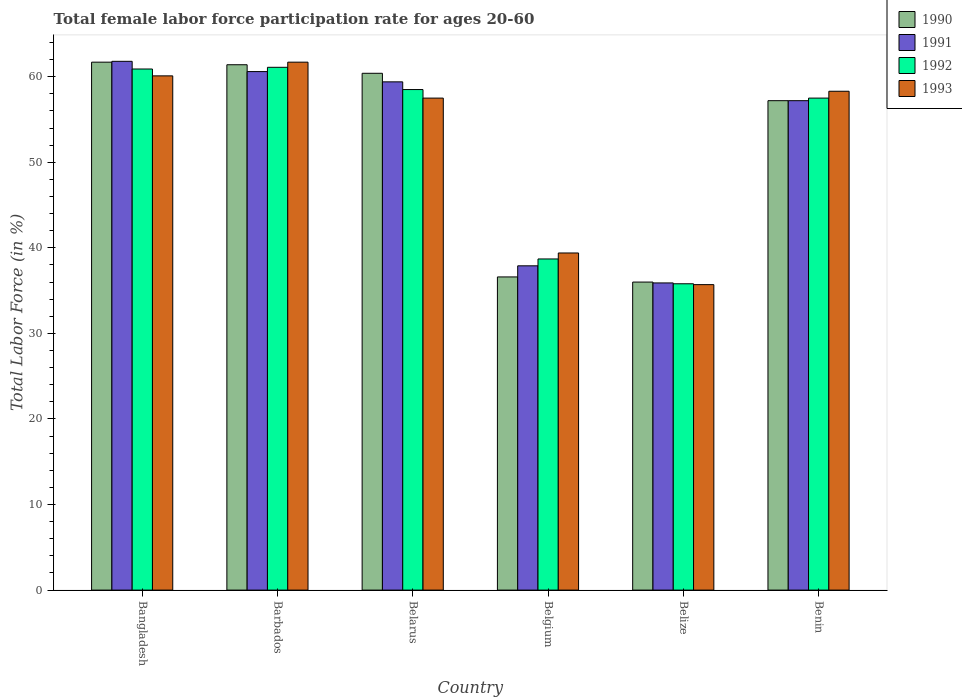How many different coloured bars are there?
Make the answer very short. 4. How many groups of bars are there?
Provide a short and direct response. 6. Are the number of bars per tick equal to the number of legend labels?
Your response must be concise. Yes. Are the number of bars on each tick of the X-axis equal?
Ensure brevity in your answer.  Yes. How many bars are there on the 3rd tick from the left?
Provide a succinct answer. 4. What is the label of the 5th group of bars from the left?
Provide a short and direct response. Belize. What is the female labor force participation rate in 1993 in Belarus?
Keep it short and to the point. 57.5. Across all countries, what is the maximum female labor force participation rate in 1993?
Make the answer very short. 61.7. Across all countries, what is the minimum female labor force participation rate in 1992?
Make the answer very short. 35.8. In which country was the female labor force participation rate in 1993 minimum?
Ensure brevity in your answer.  Belize. What is the total female labor force participation rate in 1992 in the graph?
Keep it short and to the point. 312.5. What is the difference between the female labor force participation rate in 1990 in Barbados and that in Benin?
Offer a very short reply. 4.2. What is the average female labor force participation rate in 1993 per country?
Your response must be concise. 52.12. What is the difference between the female labor force participation rate of/in 1990 and female labor force participation rate of/in 1993 in Belgium?
Make the answer very short. -2.8. In how many countries, is the female labor force participation rate in 1991 greater than 50 %?
Provide a short and direct response. 4. What is the ratio of the female labor force participation rate in 1992 in Bangladesh to that in Belgium?
Your answer should be compact. 1.57. Is the difference between the female labor force participation rate in 1990 in Belarus and Belgium greater than the difference between the female labor force participation rate in 1993 in Belarus and Belgium?
Ensure brevity in your answer.  Yes. What is the difference between the highest and the second highest female labor force participation rate in 1993?
Offer a terse response. -1.8. What is the difference between the highest and the lowest female labor force participation rate in 1990?
Provide a short and direct response. 25.7. In how many countries, is the female labor force participation rate in 1991 greater than the average female labor force participation rate in 1991 taken over all countries?
Offer a very short reply. 4. Is it the case that in every country, the sum of the female labor force participation rate in 1993 and female labor force participation rate in 1990 is greater than the sum of female labor force participation rate in 1991 and female labor force participation rate in 1992?
Your response must be concise. No. What does the 4th bar from the right in Belize represents?
Keep it short and to the point. 1990. Are all the bars in the graph horizontal?
Your response must be concise. No. Does the graph contain any zero values?
Offer a terse response. No. Where does the legend appear in the graph?
Provide a succinct answer. Top right. How many legend labels are there?
Offer a very short reply. 4. What is the title of the graph?
Make the answer very short. Total female labor force participation rate for ages 20-60. Does "2003" appear as one of the legend labels in the graph?
Give a very brief answer. No. What is the label or title of the X-axis?
Provide a short and direct response. Country. What is the label or title of the Y-axis?
Ensure brevity in your answer.  Total Labor Force (in %). What is the Total Labor Force (in %) in 1990 in Bangladesh?
Keep it short and to the point. 61.7. What is the Total Labor Force (in %) of 1991 in Bangladesh?
Keep it short and to the point. 61.8. What is the Total Labor Force (in %) of 1992 in Bangladesh?
Offer a terse response. 60.9. What is the Total Labor Force (in %) in 1993 in Bangladesh?
Your response must be concise. 60.1. What is the Total Labor Force (in %) in 1990 in Barbados?
Your answer should be very brief. 61.4. What is the Total Labor Force (in %) of 1991 in Barbados?
Offer a terse response. 60.6. What is the Total Labor Force (in %) in 1992 in Barbados?
Your answer should be very brief. 61.1. What is the Total Labor Force (in %) in 1993 in Barbados?
Provide a short and direct response. 61.7. What is the Total Labor Force (in %) in 1990 in Belarus?
Your response must be concise. 60.4. What is the Total Labor Force (in %) in 1991 in Belarus?
Your answer should be very brief. 59.4. What is the Total Labor Force (in %) of 1992 in Belarus?
Your answer should be compact. 58.5. What is the Total Labor Force (in %) of 1993 in Belarus?
Provide a succinct answer. 57.5. What is the Total Labor Force (in %) in 1990 in Belgium?
Give a very brief answer. 36.6. What is the Total Labor Force (in %) of 1991 in Belgium?
Make the answer very short. 37.9. What is the Total Labor Force (in %) of 1992 in Belgium?
Your answer should be compact. 38.7. What is the Total Labor Force (in %) in 1993 in Belgium?
Offer a terse response. 39.4. What is the Total Labor Force (in %) in 1991 in Belize?
Your answer should be very brief. 35.9. What is the Total Labor Force (in %) of 1992 in Belize?
Provide a short and direct response. 35.8. What is the Total Labor Force (in %) in 1993 in Belize?
Provide a succinct answer. 35.7. What is the Total Labor Force (in %) in 1990 in Benin?
Make the answer very short. 57.2. What is the Total Labor Force (in %) in 1991 in Benin?
Ensure brevity in your answer.  57.2. What is the Total Labor Force (in %) of 1992 in Benin?
Keep it short and to the point. 57.5. What is the Total Labor Force (in %) of 1993 in Benin?
Ensure brevity in your answer.  58.3. Across all countries, what is the maximum Total Labor Force (in %) of 1990?
Give a very brief answer. 61.7. Across all countries, what is the maximum Total Labor Force (in %) of 1991?
Provide a short and direct response. 61.8. Across all countries, what is the maximum Total Labor Force (in %) of 1992?
Your answer should be very brief. 61.1. Across all countries, what is the maximum Total Labor Force (in %) of 1993?
Ensure brevity in your answer.  61.7. Across all countries, what is the minimum Total Labor Force (in %) of 1990?
Make the answer very short. 36. Across all countries, what is the minimum Total Labor Force (in %) of 1991?
Your answer should be very brief. 35.9. Across all countries, what is the minimum Total Labor Force (in %) of 1992?
Make the answer very short. 35.8. Across all countries, what is the minimum Total Labor Force (in %) of 1993?
Your response must be concise. 35.7. What is the total Total Labor Force (in %) in 1990 in the graph?
Offer a very short reply. 313.3. What is the total Total Labor Force (in %) of 1991 in the graph?
Provide a short and direct response. 312.8. What is the total Total Labor Force (in %) in 1992 in the graph?
Give a very brief answer. 312.5. What is the total Total Labor Force (in %) of 1993 in the graph?
Keep it short and to the point. 312.7. What is the difference between the Total Labor Force (in %) in 1992 in Bangladesh and that in Barbados?
Make the answer very short. -0.2. What is the difference between the Total Labor Force (in %) in 1993 in Bangladesh and that in Barbados?
Provide a succinct answer. -1.6. What is the difference between the Total Labor Force (in %) in 1991 in Bangladesh and that in Belarus?
Make the answer very short. 2.4. What is the difference between the Total Labor Force (in %) of 1990 in Bangladesh and that in Belgium?
Offer a terse response. 25.1. What is the difference between the Total Labor Force (in %) of 1991 in Bangladesh and that in Belgium?
Offer a terse response. 23.9. What is the difference between the Total Labor Force (in %) of 1992 in Bangladesh and that in Belgium?
Offer a very short reply. 22.2. What is the difference between the Total Labor Force (in %) in 1993 in Bangladesh and that in Belgium?
Make the answer very short. 20.7. What is the difference between the Total Labor Force (in %) in 1990 in Bangladesh and that in Belize?
Your answer should be compact. 25.7. What is the difference between the Total Labor Force (in %) of 1991 in Bangladesh and that in Belize?
Your answer should be compact. 25.9. What is the difference between the Total Labor Force (in %) of 1992 in Bangladesh and that in Belize?
Your response must be concise. 25.1. What is the difference between the Total Labor Force (in %) of 1993 in Bangladesh and that in Belize?
Provide a succinct answer. 24.4. What is the difference between the Total Labor Force (in %) in 1990 in Bangladesh and that in Benin?
Your answer should be very brief. 4.5. What is the difference between the Total Labor Force (in %) in 1993 in Bangladesh and that in Benin?
Provide a short and direct response. 1.8. What is the difference between the Total Labor Force (in %) of 1991 in Barbados and that in Belarus?
Your response must be concise. 1.2. What is the difference between the Total Labor Force (in %) in 1992 in Barbados and that in Belarus?
Give a very brief answer. 2.6. What is the difference between the Total Labor Force (in %) in 1993 in Barbados and that in Belarus?
Ensure brevity in your answer.  4.2. What is the difference between the Total Labor Force (in %) in 1990 in Barbados and that in Belgium?
Give a very brief answer. 24.8. What is the difference between the Total Labor Force (in %) of 1991 in Barbados and that in Belgium?
Your answer should be very brief. 22.7. What is the difference between the Total Labor Force (in %) of 1992 in Barbados and that in Belgium?
Offer a terse response. 22.4. What is the difference between the Total Labor Force (in %) of 1993 in Barbados and that in Belgium?
Offer a terse response. 22.3. What is the difference between the Total Labor Force (in %) in 1990 in Barbados and that in Belize?
Your answer should be compact. 25.4. What is the difference between the Total Labor Force (in %) of 1991 in Barbados and that in Belize?
Make the answer very short. 24.7. What is the difference between the Total Labor Force (in %) in 1992 in Barbados and that in Belize?
Your answer should be very brief. 25.3. What is the difference between the Total Labor Force (in %) of 1990 in Barbados and that in Benin?
Your answer should be very brief. 4.2. What is the difference between the Total Labor Force (in %) in 1991 in Barbados and that in Benin?
Make the answer very short. 3.4. What is the difference between the Total Labor Force (in %) in 1993 in Barbados and that in Benin?
Make the answer very short. 3.4. What is the difference between the Total Labor Force (in %) in 1990 in Belarus and that in Belgium?
Offer a very short reply. 23.8. What is the difference between the Total Labor Force (in %) in 1992 in Belarus and that in Belgium?
Your answer should be compact. 19.8. What is the difference between the Total Labor Force (in %) in 1993 in Belarus and that in Belgium?
Ensure brevity in your answer.  18.1. What is the difference between the Total Labor Force (in %) in 1990 in Belarus and that in Belize?
Offer a very short reply. 24.4. What is the difference between the Total Labor Force (in %) in 1991 in Belarus and that in Belize?
Your answer should be compact. 23.5. What is the difference between the Total Labor Force (in %) in 1992 in Belarus and that in Belize?
Offer a very short reply. 22.7. What is the difference between the Total Labor Force (in %) of 1993 in Belarus and that in Belize?
Give a very brief answer. 21.8. What is the difference between the Total Labor Force (in %) in 1990 in Belarus and that in Benin?
Your answer should be very brief. 3.2. What is the difference between the Total Labor Force (in %) of 1991 in Belarus and that in Benin?
Offer a terse response. 2.2. What is the difference between the Total Labor Force (in %) of 1990 in Belgium and that in Belize?
Your response must be concise. 0.6. What is the difference between the Total Labor Force (in %) in 1992 in Belgium and that in Belize?
Your response must be concise. 2.9. What is the difference between the Total Labor Force (in %) in 1990 in Belgium and that in Benin?
Your response must be concise. -20.6. What is the difference between the Total Labor Force (in %) in 1991 in Belgium and that in Benin?
Keep it short and to the point. -19.3. What is the difference between the Total Labor Force (in %) of 1992 in Belgium and that in Benin?
Offer a terse response. -18.8. What is the difference between the Total Labor Force (in %) in 1993 in Belgium and that in Benin?
Make the answer very short. -18.9. What is the difference between the Total Labor Force (in %) in 1990 in Belize and that in Benin?
Provide a succinct answer. -21.2. What is the difference between the Total Labor Force (in %) of 1991 in Belize and that in Benin?
Your answer should be compact. -21.3. What is the difference between the Total Labor Force (in %) of 1992 in Belize and that in Benin?
Your response must be concise. -21.7. What is the difference between the Total Labor Force (in %) in 1993 in Belize and that in Benin?
Provide a succinct answer. -22.6. What is the difference between the Total Labor Force (in %) in 1990 in Bangladesh and the Total Labor Force (in %) in 1992 in Barbados?
Keep it short and to the point. 0.6. What is the difference between the Total Labor Force (in %) of 1990 in Bangladesh and the Total Labor Force (in %) of 1993 in Barbados?
Offer a very short reply. 0. What is the difference between the Total Labor Force (in %) in 1991 in Bangladesh and the Total Labor Force (in %) in 1992 in Barbados?
Make the answer very short. 0.7. What is the difference between the Total Labor Force (in %) of 1991 in Bangladesh and the Total Labor Force (in %) of 1993 in Barbados?
Give a very brief answer. 0.1. What is the difference between the Total Labor Force (in %) in 1992 in Bangladesh and the Total Labor Force (in %) in 1993 in Barbados?
Ensure brevity in your answer.  -0.8. What is the difference between the Total Labor Force (in %) of 1991 in Bangladesh and the Total Labor Force (in %) of 1993 in Belarus?
Keep it short and to the point. 4.3. What is the difference between the Total Labor Force (in %) in 1990 in Bangladesh and the Total Labor Force (in %) in 1991 in Belgium?
Your answer should be compact. 23.8. What is the difference between the Total Labor Force (in %) in 1990 in Bangladesh and the Total Labor Force (in %) in 1993 in Belgium?
Give a very brief answer. 22.3. What is the difference between the Total Labor Force (in %) of 1991 in Bangladesh and the Total Labor Force (in %) of 1992 in Belgium?
Ensure brevity in your answer.  23.1. What is the difference between the Total Labor Force (in %) in 1991 in Bangladesh and the Total Labor Force (in %) in 1993 in Belgium?
Your response must be concise. 22.4. What is the difference between the Total Labor Force (in %) of 1990 in Bangladesh and the Total Labor Force (in %) of 1991 in Belize?
Offer a very short reply. 25.8. What is the difference between the Total Labor Force (in %) of 1990 in Bangladesh and the Total Labor Force (in %) of 1992 in Belize?
Give a very brief answer. 25.9. What is the difference between the Total Labor Force (in %) in 1990 in Bangladesh and the Total Labor Force (in %) in 1993 in Belize?
Keep it short and to the point. 26. What is the difference between the Total Labor Force (in %) in 1991 in Bangladesh and the Total Labor Force (in %) in 1992 in Belize?
Your answer should be very brief. 26. What is the difference between the Total Labor Force (in %) of 1991 in Bangladesh and the Total Labor Force (in %) of 1993 in Belize?
Your answer should be compact. 26.1. What is the difference between the Total Labor Force (in %) in 1992 in Bangladesh and the Total Labor Force (in %) in 1993 in Belize?
Your answer should be compact. 25.2. What is the difference between the Total Labor Force (in %) in 1990 in Bangladesh and the Total Labor Force (in %) in 1991 in Benin?
Provide a succinct answer. 4.5. What is the difference between the Total Labor Force (in %) of 1990 in Bangladesh and the Total Labor Force (in %) of 1993 in Benin?
Your response must be concise. 3.4. What is the difference between the Total Labor Force (in %) of 1991 in Bangladesh and the Total Labor Force (in %) of 1992 in Benin?
Provide a short and direct response. 4.3. What is the difference between the Total Labor Force (in %) of 1991 in Bangladesh and the Total Labor Force (in %) of 1993 in Benin?
Provide a succinct answer. 3.5. What is the difference between the Total Labor Force (in %) in 1992 in Bangladesh and the Total Labor Force (in %) in 1993 in Benin?
Offer a terse response. 2.6. What is the difference between the Total Labor Force (in %) of 1990 in Barbados and the Total Labor Force (in %) of 1993 in Belarus?
Provide a short and direct response. 3.9. What is the difference between the Total Labor Force (in %) in 1991 in Barbados and the Total Labor Force (in %) in 1992 in Belarus?
Make the answer very short. 2.1. What is the difference between the Total Labor Force (in %) of 1991 in Barbados and the Total Labor Force (in %) of 1993 in Belarus?
Your response must be concise. 3.1. What is the difference between the Total Labor Force (in %) of 1990 in Barbados and the Total Labor Force (in %) of 1992 in Belgium?
Your response must be concise. 22.7. What is the difference between the Total Labor Force (in %) in 1991 in Barbados and the Total Labor Force (in %) in 1992 in Belgium?
Offer a very short reply. 21.9. What is the difference between the Total Labor Force (in %) of 1991 in Barbados and the Total Labor Force (in %) of 1993 in Belgium?
Make the answer very short. 21.2. What is the difference between the Total Labor Force (in %) of 1992 in Barbados and the Total Labor Force (in %) of 1993 in Belgium?
Provide a short and direct response. 21.7. What is the difference between the Total Labor Force (in %) of 1990 in Barbados and the Total Labor Force (in %) of 1992 in Belize?
Your answer should be very brief. 25.6. What is the difference between the Total Labor Force (in %) in 1990 in Barbados and the Total Labor Force (in %) in 1993 in Belize?
Give a very brief answer. 25.7. What is the difference between the Total Labor Force (in %) of 1991 in Barbados and the Total Labor Force (in %) of 1992 in Belize?
Ensure brevity in your answer.  24.8. What is the difference between the Total Labor Force (in %) in 1991 in Barbados and the Total Labor Force (in %) in 1993 in Belize?
Make the answer very short. 24.9. What is the difference between the Total Labor Force (in %) of 1992 in Barbados and the Total Labor Force (in %) of 1993 in Belize?
Your response must be concise. 25.4. What is the difference between the Total Labor Force (in %) of 1991 in Barbados and the Total Labor Force (in %) of 1993 in Benin?
Your response must be concise. 2.3. What is the difference between the Total Labor Force (in %) of 1990 in Belarus and the Total Labor Force (in %) of 1992 in Belgium?
Offer a terse response. 21.7. What is the difference between the Total Labor Force (in %) of 1991 in Belarus and the Total Labor Force (in %) of 1992 in Belgium?
Offer a very short reply. 20.7. What is the difference between the Total Labor Force (in %) in 1992 in Belarus and the Total Labor Force (in %) in 1993 in Belgium?
Make the answer very short. 19.1. What is the difference between the Total Labor Force (in %) in 1990 in Belarus and the Total Labor Force (in %) in 1992 in Belize?
Offer a very short reply. 24.6. What is the difference between the Total Labor Force (in %) of 1990 in Belarus and the Total Labor Force (in %) of 1993 in Belize?
Provide a short and direct response. 24.7. What is the difference between the Total Labor Force (in %) of 1991 in Belarus and the Total Labor Force (in %) of 1992 in Belize?
Provide a short and direct response. 23.6. What is the difference between the Total Labor Force (in %) of 1991 in Belarus and the Total Labor Force (in %) of 1993 in Belize?
Offer a very short reply. 23.7. What is the difference between the Total Labor Force (in %) of 1992 in Belarus and the Total Labor Force (in %) of 1993 in Belize?
Provide a succinct answer. 22.8. What is the difference between the Total Labor Force (in %) of 1990 in Belarus and the Total Labor Force (in %) of 1991 in Benin?
Your response must be concise. 3.2. What is the difference between the Total Labor Force (in %) in 1990 in Belarus and the Total Labor Force (in %) in 1992 in Benin?
Your answer should be very brief. 2.9. What is the difference between the Total Labor Force (in %) of 1992 in Belarus and the Total Labor Force (in %) of 1993 in Benin?
Your answer should be very brief. 0.2. What is the difference between the Total Labor Force (in %) in 1990 in Belgium and the Total Labor Force (in %) in 1991 in Belize?
Keep it short and to the point. 0.7. What is the difference between the Total Labor Force (in %) in 1990 in Belgium and the Total Labor Force (in %) in 1993 in Belize?
Give a very brief answer. 0.9. What is the difference between the Total Labor Force (in %) in 1990 in Belgium and the Total Labor Force (in %) in 1991 in Benin?
Your answer should be compact. -20.6. What is the difference between the Total Labor Force (in %) of 1990 in Belgium and the Total Labor Force (in %) of 1992 in Benin?
Make the answer very short. -20.9. What is the difference between the Total Labor Force (in %) in 1990 in Belgium and the Total Labor Force (in %) in 1993 in Benin?
Your answer should be very brief. -21.7. What is the difference between the Total Labor Force (in %) in 1991 in Belgium and the Total Labor Force (in %) in 1992 in Benin?
Your response must be concise. -19.6. What is the difference between the Total Labor Force (in %) of 1991 in Belgium and the Total Labor Force (in %) of 1993 in Benin?
Make the answer very short. -20.4. What is the difference between the Total Labor Force (in %) in 1992 in Belgium and the Total Labor Force (in %) in 1993 in Benin?
Provide a short and direct response. -19.6. What is the difference between the Total Labor Force (in %) of 1990 in Belize and the Total Labor Force (in %) of 1991 in Benin?
Make the answer very short. -21.2. What is the difference between the Total Labor Force (in %) in 1990 in Belize and the Total Labor Force (in %) in 1992 in Benin?
Make the answer very short. -21.5. What is the difference between the Total Labor Force (in %) in 1990 in Belize and the Total Labor Force (in %) in 1993 in Benin?
Give a very brief answer. -22.3. What is the difference between the Total Labor Force (in %) of 1991 in Belize and the Total Labor Force (in %) of 1992 in Benin?
Provide a succinct answer. -21.6. What is the difference between the Total Labor Force (in %) in 1991 in Belize and the Total Labor Force (in %) in 1993 in Benin?
Provide a succinct answer. -22.4. What is the difference between the Total Labor Force (in %) in 1992 in Belize and the Total Labor Force (in %) in 1993 in Benin?
Provide a succinct answer. -22.5. What is the average Total Labor Force (in %) in 1990 per country?
Offer a very short reply. 52.22. What is the average Total Labor Force (in %) in 1991 per country?
Ensure brevity in your answer.  52.13. What is the average Total Labor Force (in %) of 1992 per country?
Give a very brief answer. 52.08. What is the average Total Labor Force (in %) of 1993 per country?
Provide a succinct answer. 52.12. What is the difference between the Total Labor Force (in %) of 1990 and Total Labor Force (in %) of 1993 in Bangladesh?
Your answer should be very brief. 1.6. What is the difference between the Total Labor Force (in %) in 1992 and Total Labor Force (in %) in 1993 in Bangladesh?
Ensure brevity in your answer.  0.8. What is the difference between the Total Labor Force (in %) of 1990 and Total Labor Force (in %) of 1992 in Barbados?
Give a very brief answer. 0.3. What is the difference between the Total Labor Force (in %) of 1991 and Total Labor Force (in %) of 1992 in Barbados?
Keep it short and to the point. -0.5. What is the difference between the Total Labor Force (in %) of 1991 and Total Labor Force (in %) of 1993 in Barbados?
Provide a short and direct response. -1.1. What is the difference between the Total Labor Force (in %) of 1992 and Total Labor Force (in %) of 1993 in Barbados?
Provide a succinct answer. -0.6. What is the difference between the Total Labor Force (in %) of 1990 and Total Labor Force (in %) of 1991 in Belarus?
Offer a very short reply. 1. What is the difference between the Total Labor Force (in %) in 1990 and Total Labor Force (in %) in 1992 in Belarus?
Give a very brief answer. 1.9. What is the difference between the Total Labor Force (in %) of 1991 and Total Labor Force (in %) of 1992 in Belarus?
Your response must be concise. 0.9. What is the difference between the Total Labor Force (in %) in 1992 and Total Labor Force (in %) in 1993 in Belarus?
Provide a succinct answer. 1. What is the difference between the Total Labor Force (in %) of 1990 and Total Labor Force (in %) of 1992 in Belgium?
Offer a very short reply. -2.1. What is the difference between the Total Labor Force (in %) of 1991 and Total Labor Force (in %) of 1992 in Belgium?
Make the answer very short. -0.8. What is the difference between the Total Labor Force (in %) of 1991 and Total Labor Force (in %) of 1993 in Belgium?
Keep it short and to the point. -1.5. What is the difference between the Total Labor Force (in %) of 1990 and Total Labor Force (in %) of 1992 in Belize?
Your response must be concise. 0.2. What is the difference between the Total Labor Force (in %) in 1991 and Total Labor Force (in %) in 1992 in Belize?
Provide a succinct answer. 0.1. What is the difference between the Total Labor Force (in %) in 1990 and Total Labor Force (in %) in 1991 in Benin?
Your answer should be very brief. 0. What is the difference between the Total Labor Force (in %) of 1990 and Total Labor Force (in %) of 1992 in Benin?
Offer a terse response. -0.3. What is the difference between the Total Labor Force (in %) in 1991 and Total Labor Force (in %) in 1993 in Benin?
Keep it short and to the point. -1.1. What is the ratio of the Total Labor Force (in %) of 1990 in Bangladesh to that in Barbados?
Make the answer very short. 1. What is the ratio of the Total Labor Force (in %) in 1991 in Bangladesh to that in Barbados?
Give a very brief answer. 1.02. What is the ratio of the Total Labor Force (in %) of 1992 in Bangladesh to that in Barbados?
Give a very brief answer. 1. What is the ratio of the Total Labor Force (in %) in 1993 in Bangladesh to that in Barbados?
Your answer should be very brief. 0.97. What is the ratio of the Total Labor Force (in %) of 1990 in Bangladesh to that in Belarus?
Your response must be concise. 1.02. What is the ratio of the Total Labor Force (in %) of 1991 in Bangladesh to that in Belarus?
Make the answer very short. 1.04. What is the ratio of the Total Labor Force (in %) in 1992 in Bangladesh to that in Belarus?
Provide a short and direct response. 1.04. What is the ratio of the Total Labor Force (in %) in 1993 in Bangladesh to that in Belarus?
Offer a very short reply. 1.05. What is the ratio of the Total Labor Force (in %) in 1990 in Bangladesh to that in Belgium?
Your response must be concise. 1.69. What is the ratio of the Total Labor Force (in %) of 1991 in Bangladesh to that in Belgium?
Keep it short and to the point. 1.63. What is the ratio of the Total Labor Force (in %) in 1992 in Bangladesh to that in Belgium?
Your response must be concise. 1.57. What is the ratio of the Total Labor Force (in %) of 1993 in Bangladesh to that in Belgium?
Keep it short and to the point. 1.53. What is the ratio of the Total Labor Force (in %) in 1990 in Bangladesh to that in Belize?
Offer a very short reply. 1.71. What is the ratio of the Total Labor Force (in %) in 1991 in Bangladesh to that in Belize?
Your answer should be very brief. 1.72. What is the ratio of the Total Labor Force (in %) of 1992 in Bangladesh to that in Belize?
Make the answer very short. 1.7. What is the ratio of the Total Labor Force (in %) in 1993 in Bangladesh to that in Belize?
Offer a terse response. 1.68. What is the ratio of the Total Labor Force (in %) of 1990 in Bangladesh to that in Benin?
Provide a succinct answer. 1.08. What is the ratio of the Total Labor Force (in %) of 1991 in Bangladesh to that in Benin?
Offer a terse response. 1.08. What is the ratio of the Total Labor Force (in %) of 1992 in Bangladesh to that in Benin?
Give a very brief answer. 1.06. What is the ratio of the Total Labor Force (in %) in 1993 in Bangladesh to that in Benin?
Keep it short and to the point. 1.03. What is the ratio of the Total Labor Force (in %) of 1990 in Barbados to that in Belarus?
Provide a succinct answer. 1.02. What is the ratio of the Total Labor Force (in %) in 1991 in Barbados to that in Belarus?
Your answer should be compact. 1.02. What is the ratio of the Total Labor Force (in %) in 1992 in Barbados to that in Belarus?
Offer a very short reply. 1.04. What is the ratio of the Total Labor Force (in %) in 1993 in Barbados to that in Belarus?
Your answer should be compact. 1.07. What is the ratio of the Total Labor Force (in %) in 1990 in Barbados to that in Belgium?
Offer a very short reply. 1.68. What is the ratio of the Total Labor Force (in %) in 1991 in Barbados to that in Belgium?
Provide a succinct answer. 1.6. What is the ratio of the Total Labor Force (in %) in 1992 in Barbados to that in Belgium?
Make the answer very short. 1.58. What is the ratio of the Total Labor Force (in %) of 1993 in Barbados to that in Belgium?
Provide a succinct answer. 1.57. What is the ratio of the Total Labor Force (in %) in 1990 in Barbados to that in Belize?
Your answer should be compact. 1.71. What is the ratio of the Total Labor Force (in %) in 1991 in Barbados to that in Belize?
Your answer should be compact. 1.69. What is the ratio of the Total Labor Force (in %) in 1992 in Barbados to that in Belize?
Offer a very short reply. 1.71. What is the ratio of the Total Labor Force (in %) in 1993 in Barbados to that in Belize?
Ensure brevity in your answer.  1.73. What is the ratio of the Total Labor Force (in %) of 1990 in Barbados to that in Benin?
Your answer should be very brief. 1.07. What is the ratio of the Total Labor Force (in %) of 1991 in Barbados to that in Benin?
Give a very brief answer. 1.06. What is the ratio of the Total Labor Force (in %) of 1992 in Barbados to that in Benin?
Offer a terse response. 1.06. What is the ratio of the Total Labor Force (in %) of 1993 in Barbados to that in Benin?
Offer a terse response. 1.06. What is the ratio of the Total Labor Force (in %) in 1990 in Belarus to that in Belgium?
Your answer should be very brief. 1.65. What is the ratio of the Total Labor Force (in %) of 1991 in Belarus to that in Belgium?
Your answer should be compact. 1.57. What is the ratio of the Total Labor Force (in %) of 1992 in Belarus to that in Belgium?
Your response must be concise. 1.51. What is the ratio of the Total Labor Force (in %) of 1993 in Belarus to that in Belgium?
Keep it short and to the point. 1.46. What is the ratio of the Total Labor Force (in %) of 1990 in Belarus to that in Belize?
Your answer should be compact. 1.68. What is the ratio of the Total Labor Force (in %) of 1991 in Belarus to that in Belize?
Make the answer very short. 1.65. What is the ratio of the Total Labor Force (in %) of 1992 in Belarus to that in Belize?
Your answer should be compact. 1.63. What is the ratio of the Total Labor Force (in %) in 1993 in Belarus to that in Belize?
Ensure brevity in your answer.  1.61. What is the ratio of the Total Labor Force (in %) in 1990 in Belarus to that in Benin?
Provide a short and direct response. 1.06. What is the ratio of the Total Labor Force (in %) in 1991 in Belarus to that in Benin?
Give a very brief answer. 1.04. What is the ratio of the Total Labor Force (in %) in 1992 in Belarus to that in Benin?
Make the answer very short. 1.02. What is the ratio of the Total Labor Force (in %) of 1993 in Belarus to that in Benin?
Provide a short and direct response. 0.99. What is the ratio of the Total Labor Force (in %) in 1990 in Belgium to that in Belize?
Ensure brevity in your answer.  1.02. What is the ratio of the Total Labor Force (in %) of 1991 in Belgium to that in Belize?
Your answer should be compact. 1.06. What is the ratio of the Total Labor Force (in %) in 1992 in Belgium to that in Belize?
Your response must be concise. 1.08. What is the ratio of the Total Labor Force (in %) in 1993 in Belgium to that in Belize?
Your answer should be very brief. 1.1. What is the ratio of the Total Labor Force (in %) in 1990 in Belgium to that in Benin?
Make the answer very short. 0.64. What is the ratio of the Total Labor Force (in %) in 1991 in Belgium to that in Benin?
Keep it short and to the point. 0.66. What is the ratio of the Total Labor Force (in %) of 1992 in Belgium to that in Benin?
Keep it short and to the point. 0.67. What is the ratio of the Total Labor Force (in %) of 1993 in Belgium to that in Benin?
Provide a short and direct response. 0.68. What is the ratio of the Total Labor Force (in %) of 1990 in Belize to that in Benin?
Ensure brevity in your answer.  0.63. What is the ratio of the Total Labor Force (in %) of 1991 in Belize to that in Benin?
Offer a very short reply. 0.63. What is the ratio of the Total Labor Force (in %) of 1992 in Belize to that in Benin?
Provide a short and direct response. 0.62. What is the ratio of the Total Labor Force (in %) of 1993 in Belize to that in Benin?
Your response must be concise. 0.61. What is the difference between the highest and the second highest Total Labor Force (in %) in 1990?
Provide a short and direct response. 0.3. What is the difference between the highest and the lowest Total Labor Force (in %) of 1990?
Provide a short and direct response. 25.7. What is the difference between the highest and the lowest Total Labor Force (in %) in 1991?
Make the answer very short. 25.9. What is the difference between the highest and the lowest Total Labor Force (in %) of 1992?
Provide a succinct answer. 25.3. 